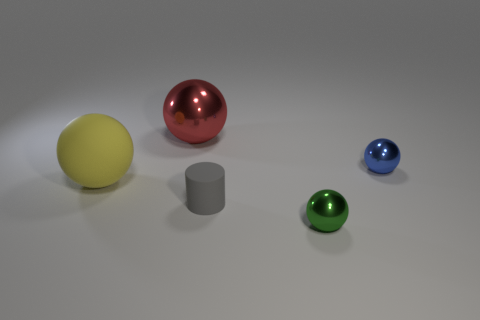Are there any small shiny balls in front of the large yellow rubber ball behind the object that is in front of the small matte cylinder? Yes, there is a small shiny red ball positioned in front of the large yellow rubber ball which is itself behind the grey matte cylinder. 